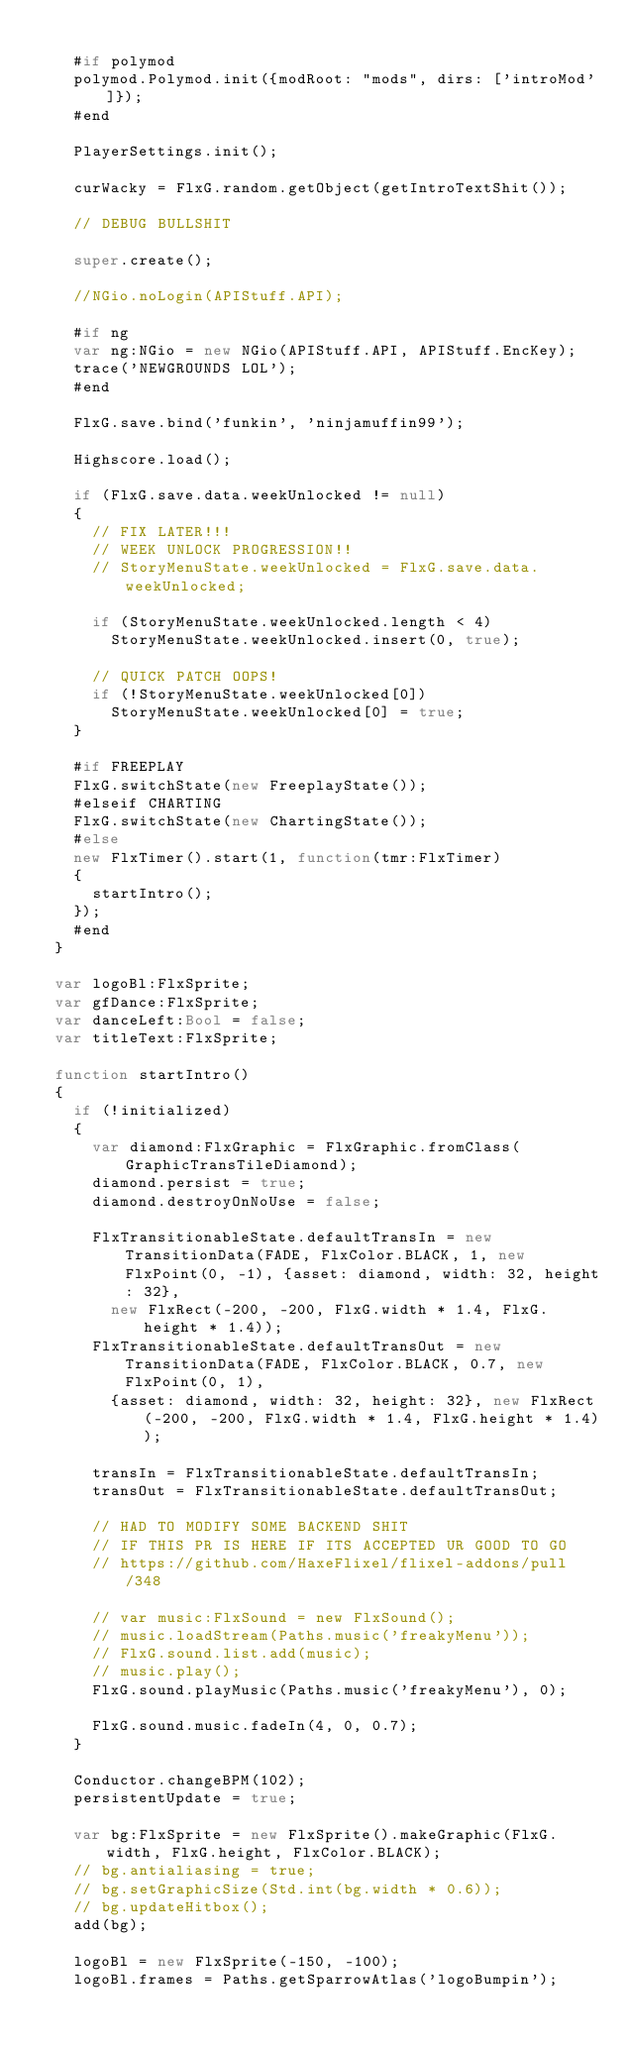Convert code to text. <code><loc_0><loc_0><loc_500><loc_500><_Haxe_>		
		#if polymod
		polymod.Polymod.init({modRoot: "mods", dirs: ['introMod']});
		#end
		
		PlayerSettings.init();

		curWacky = FlxG.random.getObject(getIntroTextShit());

		// DEBUG BULLSHIT

		super.create();

		//NGio.noLogin(APIStuff.API);

		#if ng
		var ng:NGio = new NGio(APIStuff.API, APIStuff.EncKey);
		trace('NEWGROUNDS LOL');
		#end

		FlxG.save.bind('funkin', 'ninjamuffin99');

		Highscore.load();

		if (FlxG.save.data.weekUnlocked != null)
		{
			// FIX LATER!!!
			// WEEK UNLOCK PROGRESSION!!
			// StoryMenuState.weekUnlocked = FlxG.save.data.weekUnlocked;

			if (StoryMenuState.weekUnlocked.length < 4)
				StoryMenuState.weekUnlocked.insert(0, true);

			// QUICK PATCH OOPS!
			if (!StoryMenuState.weekUnlocked[0])
				StoryMenuState.weekUnlocked[0] = true;
		}

		#if FREEPLAY
		FlxG.switchState(new FreeplayState());
		#elseif CHARTING
		FlxG.switchState(new ChartingState());
		#else
		new FlxTimer().start(1, function(tmr:FlxTimer)
		{
			startIntro();
		});
		#end
	}

	var logoBl:FlxSprite;
	var gfDance:FlxSprite;
	var danceLeft:Bool = false;
	var titleText:FlxSprite;

	function startIntro()
	{
		if (!initialized)
		{
			var diamond:FlxGraphic = FlxGraphic.fromClass(GraphicTransTileDiamond);
			diamond.persist = true;
			diamond.destroyOnNoUse = false;

			FlxTransitionableState.defaultTransIn = new TransitionData(FADE, FlxColor.BLACK, 1, new FlxPoint(0, -1), {asset: diamond, width: 32, height: 32},
				new FlxRect(-200, -200, FlxG.width * 1.4, FlxG.height * 1.4));
			FlxTransitionableState.defaultTransOut = new TransitionData(FADE, FlxColor.BLACK, 0.7, new FlxPoint(0, 1),
				{asset: diamond, width: 32, height: 32}, new FlxRect(-200, -200, FlxG.width * 1.4, FlxG.height * 1.4));

			transIn = FlxTransitionableState.defaultTransIn;
			transOut = FlxTransitionableState.defaultTransOut;

			// HAD TO MODIFY SOME BACKEND SHIT
			// IF THIS PR IS HERE IF ITS ACCEPTED UR GOOD TO GO
			// https://github.com/HaxeFlixel/flixel-addons/pull/348

			// var music:FlxSound = new FlxSound();
			// music.loadStream(Paths.music('freakyMenu'));
			// FlxG.sound.list.add(music);
			// music.play();
			FlxG.sound.playMusic(Paths.music('freakyMenu'), 0);

			FlxG.sound.music.fadeIn(4, 0, 0.7);
		}

		Conductor.changeBPM(102);
		persistentUpdate = true;

		var bg:FlxSprite = new FlxSprite().makeGraphic(FlxG.width, FlxG.height, FlxColor.BLACK);
		// bg.antialiasing = true;
		// bg.setGraphicSize(Std.int(bg.width * 0.6));
		// bg.updateHitbox();
		add(bg);

		logoBl = new FlxSprite(-150, -100);
		logoBl.frames = Paths.getSparrowAtlas('logoBumpin');</code> 